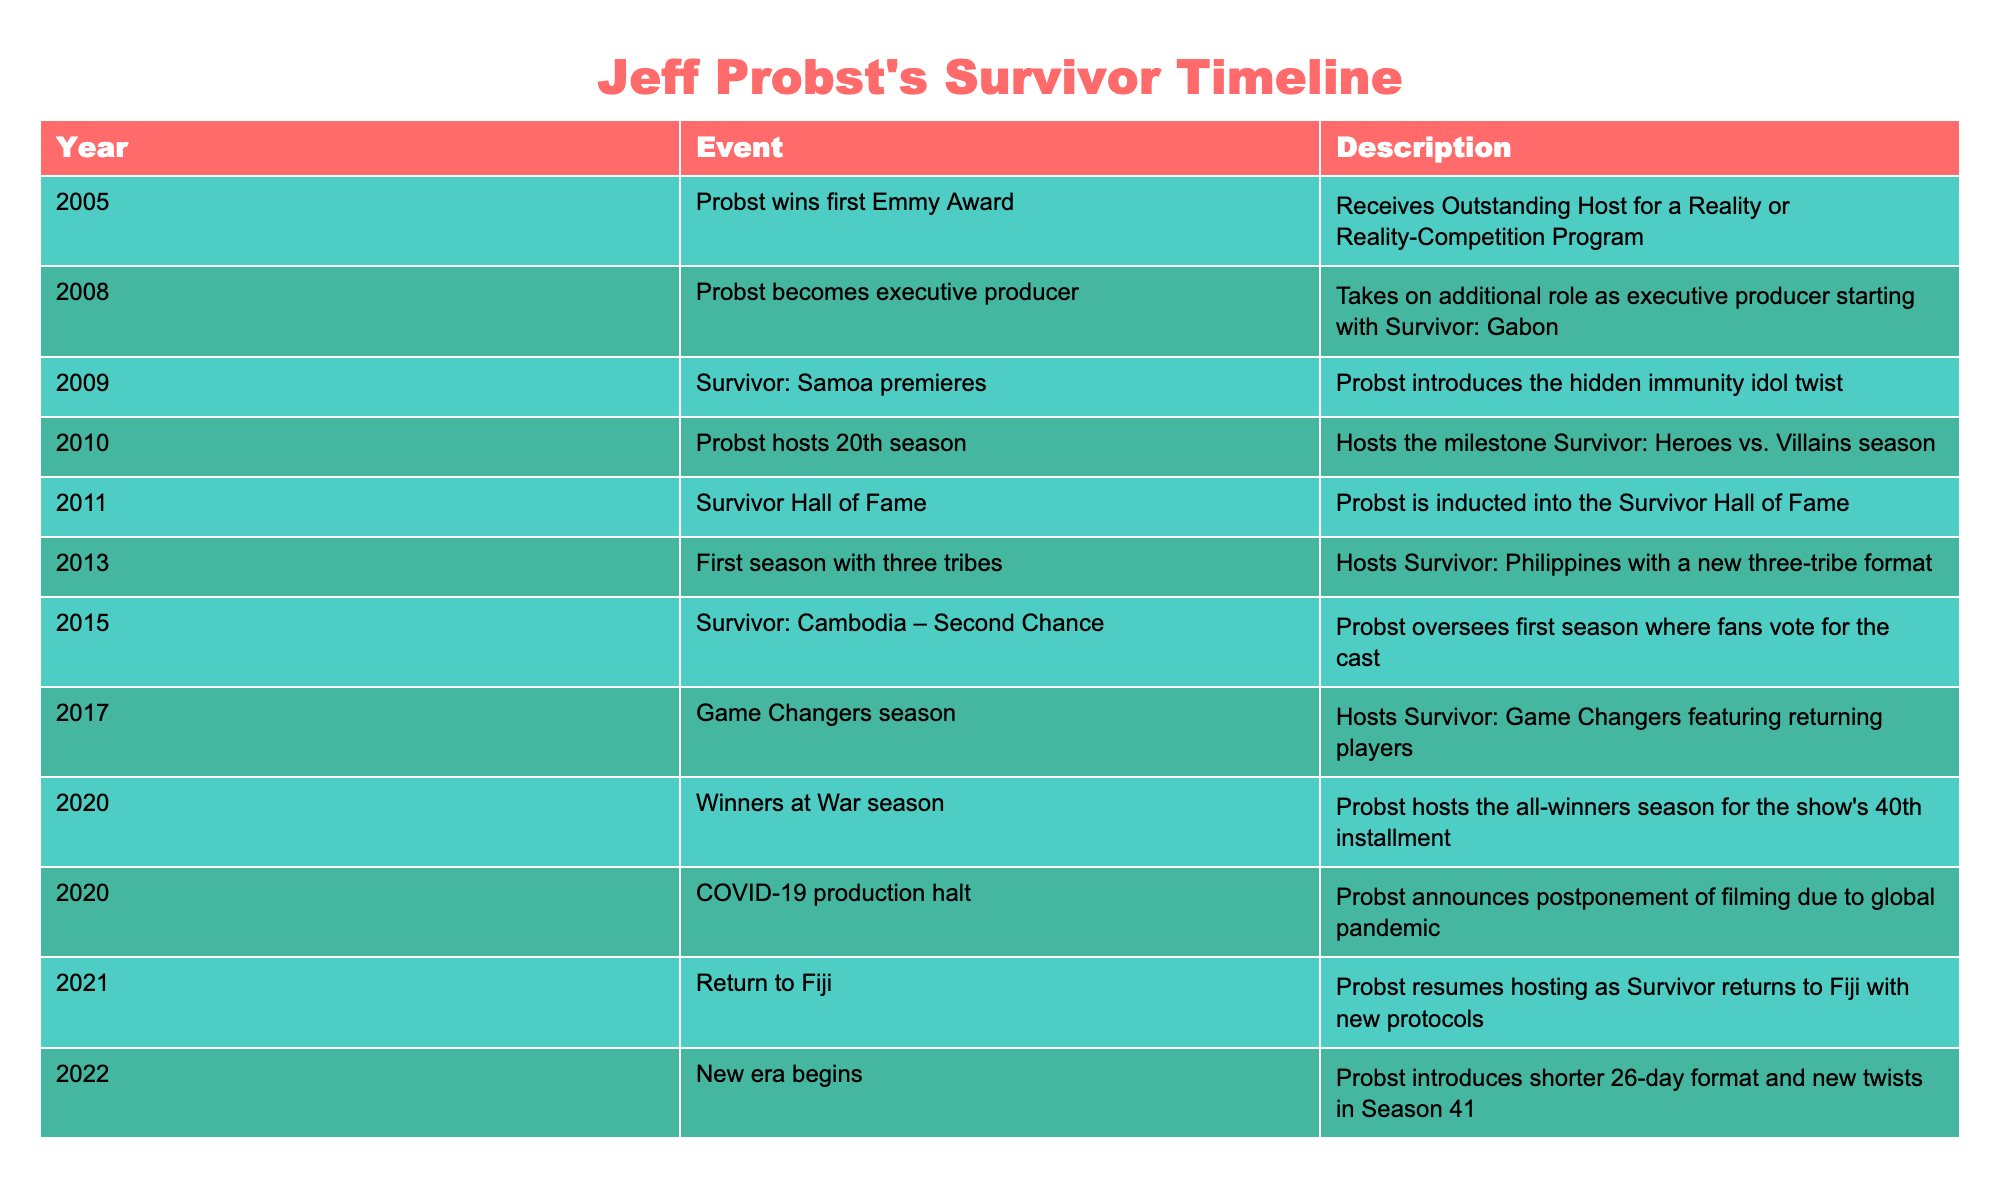What year did Jeff Probst win his first Emmy Award? According to the table, Jeff Probst won his first Emmy Award in 2005. The "Year" column indicates the event of him receiving the award for Outstanding Host for a Reality or Reality-Competition Program in that year.
Answer: 2005 In what year did Jeff Probst become an executive producer? The table specifies that Probst took on the additional role as executive producer starting in 2008, indicating this change in his career occurred that year.
Answer: 2008 How many years passed between Probst hosting his 20th season and being inducted into the Survivor Hall of Fame? Jeff Probst hosted the 20th season in 2010 and was inducted into the Survivor Hall of Fame in 2011. The difference between 2011 and 2010 is 1 year.
Answer: 1 year Did Probst introduce the three-tribe format before or after the Survivor Hall of Fame induction? The table shows that the Survivor Hall of Fame induction occurred in 2011 and the introduction of the three-tribe format was in 2013. Therefore, Probst introduced the three-tribe format after his Hall of Fame induction.
Answer: After What was a significant change in Survivor format introduced in 2022? The table indicates that in 2022, Probst introduced a shorter 26-day format with new twists in Season 41, representing a significant change in how the show was structured compared to previous seasons.
Answer: 26-day format How many seasons did he host before introducing the hidden immunity idol twist? Probst hosted Survivor: Samoa in 2009, which was where he introduced the hidden immunity idol twist. Referring to the timeline, there are 8 seasons before this introduction starting from 2005.
Answer: 8 seasons Was there a break in filming Survivor due to the COVID-19 pandemic? The table confirms that there was a COVID-19 production halt in 2020, during which Probst announced the postponement of filming due to the global pandemic, indicating that filming was indeed halted.
Answer: Yes What major milestone did Survivor reach in 2020 with Probst as host? Probst hosted the all-winners season for the show's 40th installment in 2020, marking a significant milestone in the history of Survivor.
Answer: 40th installment 